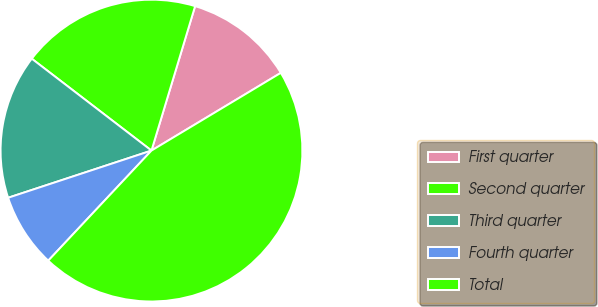<chart> <loc_0><loc_0><loc_500><loc_500><pie_chart><fcel>First quarter<fcel>Second quarter<fcel>Third quarter<fcel>Fourth quarter<fcel>Total<nl><fcel>11.72%<fcel>19.25%<fcel>15.48%<fcel>7.95%<fcel>45.6%<nl></chart> 